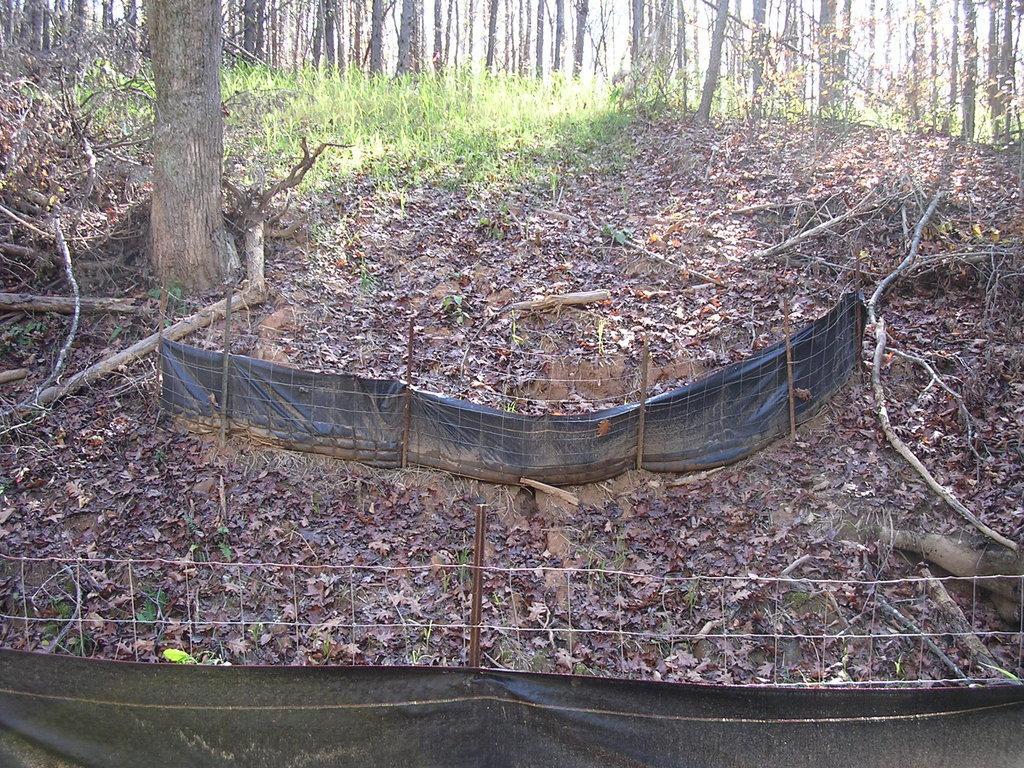How would you summarize this image in a sentence or two? At the bottom there is a net to which a black color cloth is attached. In the middle of the image there is another net on the ground. In the background, I can see the plants on the ground. At the top there are many trees. 